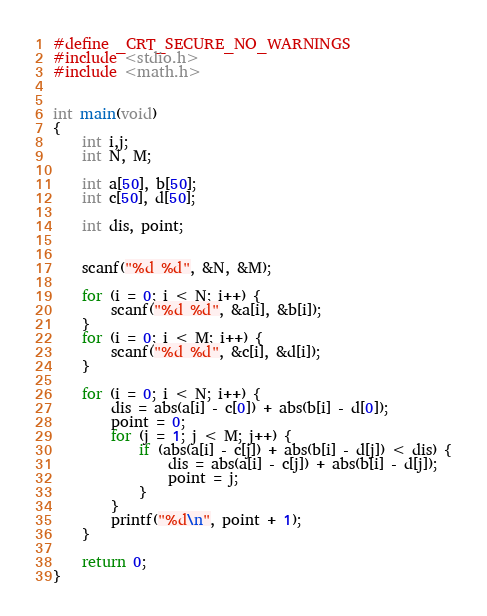Convert code to text. <code><loc_0><loc_0><loc_500><loc_500><_C++_>#define _CRT_SECURE_NO_WARNINGS
#include <stdio.h>
#include <math.h>


int main(void)
{
	int i,j;
	int N, M;

	int a[50], b[50];
	int c[50], d[50];

	int dis, point;


	scanf("%d %d", &N, &M);

	for (i = 0; i < N; i++) {
		scanf("%d %d", &a[i], &b[i]);
	}
	for (i = 0; i < M; i++) {
		scanf("%d %d", &c[i], &d[i]);
	}

	for (i = 0; i < N; i++) {
		dis = abs(a[i] - c[0]) + abs(b[i] - d[0]);
		point = 0;
		for (j = 1; j < M; j++) {
			if (abs(a[i] - c[j]) + abs(b[i] - d[j]) < dis) {
				dis = abs(a[i] - c[j]) + abs(b[i] - d[j]);
				point = j;
			}
		}
		printf("%d\n", point + 1);
	}

	return 0;
}
</code> 